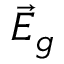<formula> <loc_0><loc_0><loc_500><loc_500>\vec { E } _ { g }</formula> 